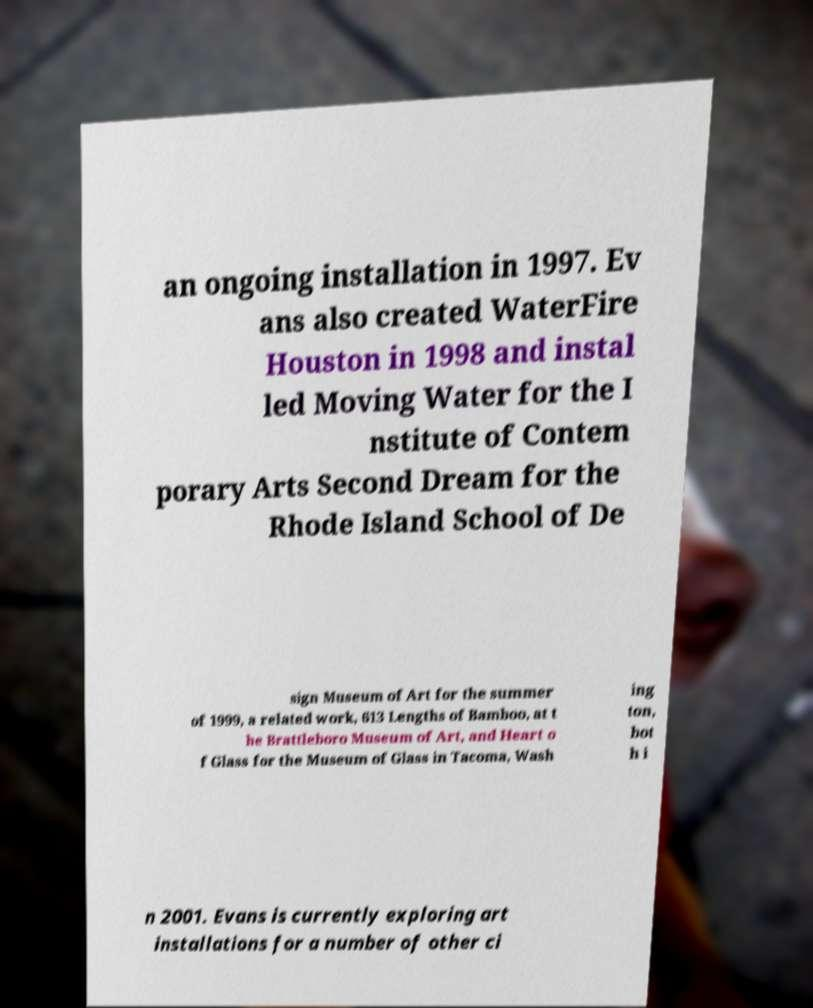Please identify and transcribe the text found in this image. an ongoing installation in 1997. Ev ans also created WaterFire Houston in 1998 and instal led Moving Water for the I nstitute of Contem porary Arts Second Dream for the Rhode Island School of De sign Museum of Art for the summer of 1999, a related work, 613 Lengths of Bamboo, at t he Brattleboro Museum of Art, and Heart o f Glass for the Museum of Glass in Tacoma, Wash ing ton, bot h i n 2001. Evans is currently exploring art installations for a number of other ci 